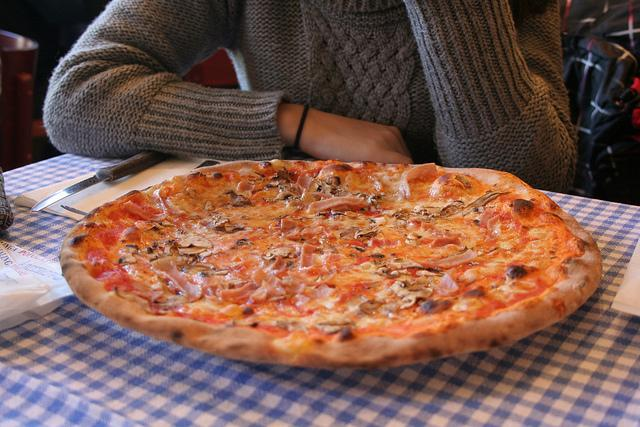How many distinct topping types are on this pizza? three 